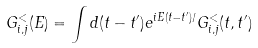Convert formula to latex. <formula><loc_0><loc_0><loc_500><loc_500>G ^ { < } _ { i , j } ( E ) = \int d ( t - t ^ { \prime } ) e ^ { i E ( t - t ^ { \prime } ) / } G ^ { < } _ { i , j } ( t , t ^ { \prime } )</formula> 